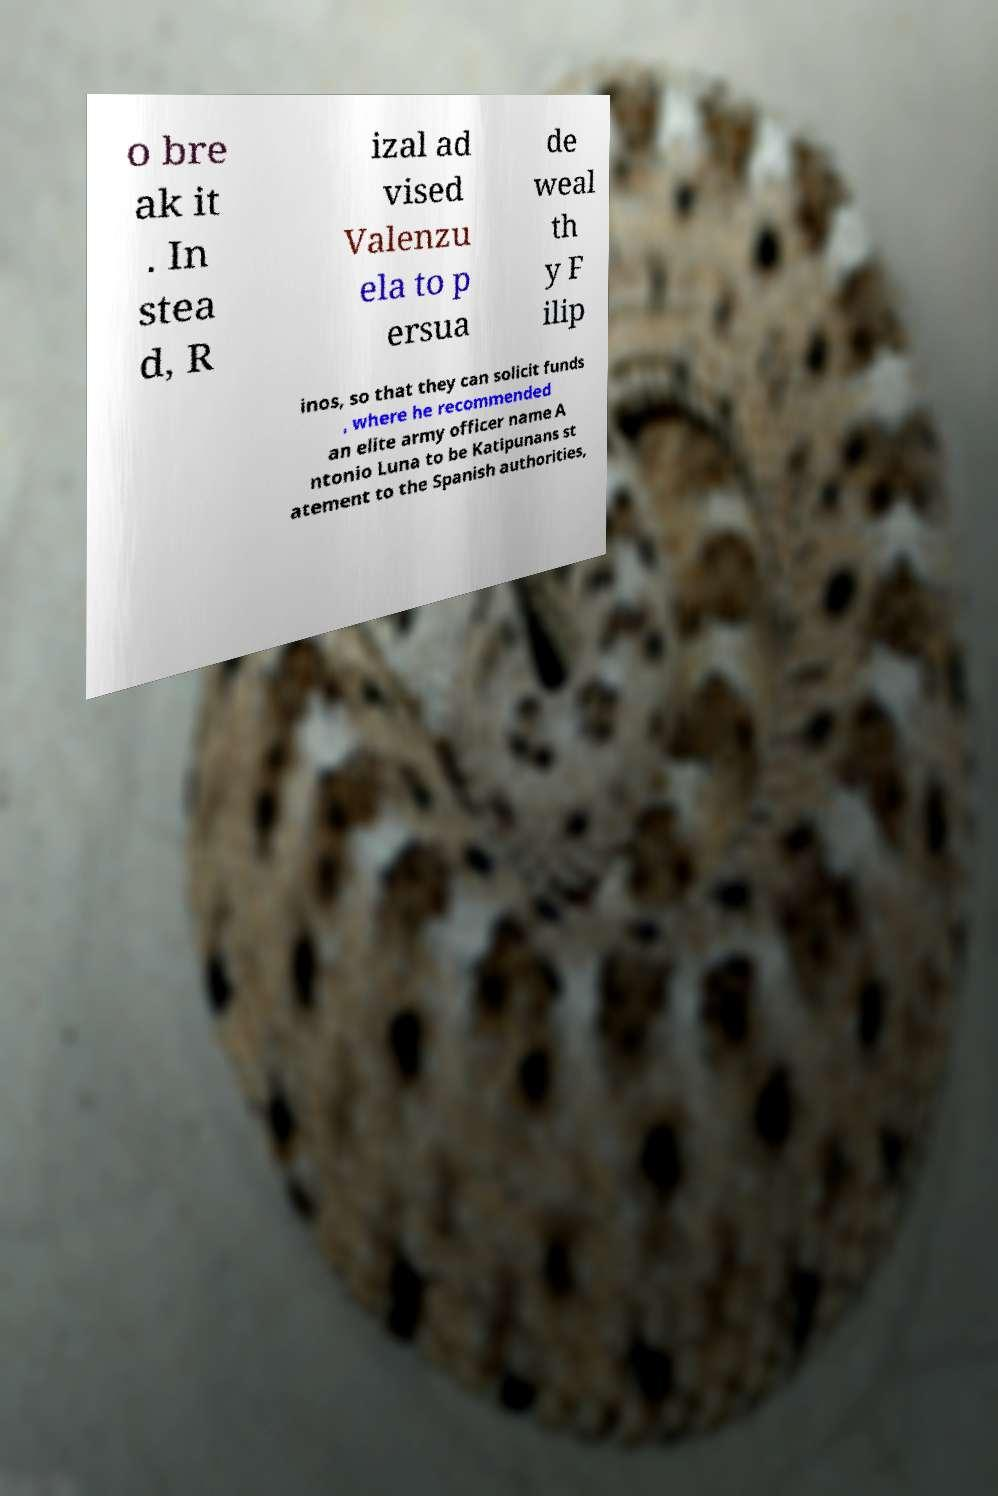For documentation purposes, I need the text within this image transcribed. Could you provide that? o bre ak it . In stea d, R izal ad vised Valenzu ela to p ersua de weal th y F ilip inos, so that they can solicit funds , where he recommended an elite army officer name A ntonio Luna to be Katipunans st atement to the Spanish authorities, 